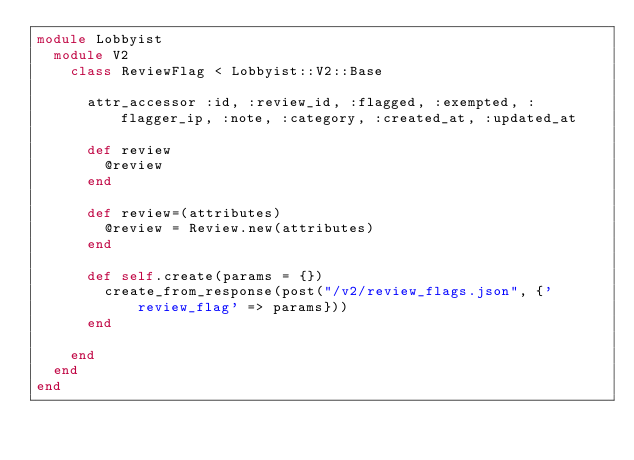Convert code to text. <code><loc_0><loc_0><loc_500><loc_500><_Ruby_>module Lobbyist
  module V2
    class ReviewFlag < Lobbyist::V2::Base

      attr_accessor :id, :review_id, :flagged, :exempted, :flagger_ip, :note, :category, :created_at, :updated_at

      def review
        @review
      end

      def review=(attributes)
        @review = Review.new(attributes)
      end

      def self.create(params = {})
        create_from_response(post("/v2/review_flags.json", {'review_flag' => params}))
      end

    end
  end
end
</code> 